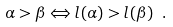<formula> <loc_0><loc_0><loc_500><loc_500>\alpha > \beta \Leftrightarrow l ( \alpha ) > l ( \beta ) \ .</formula> 